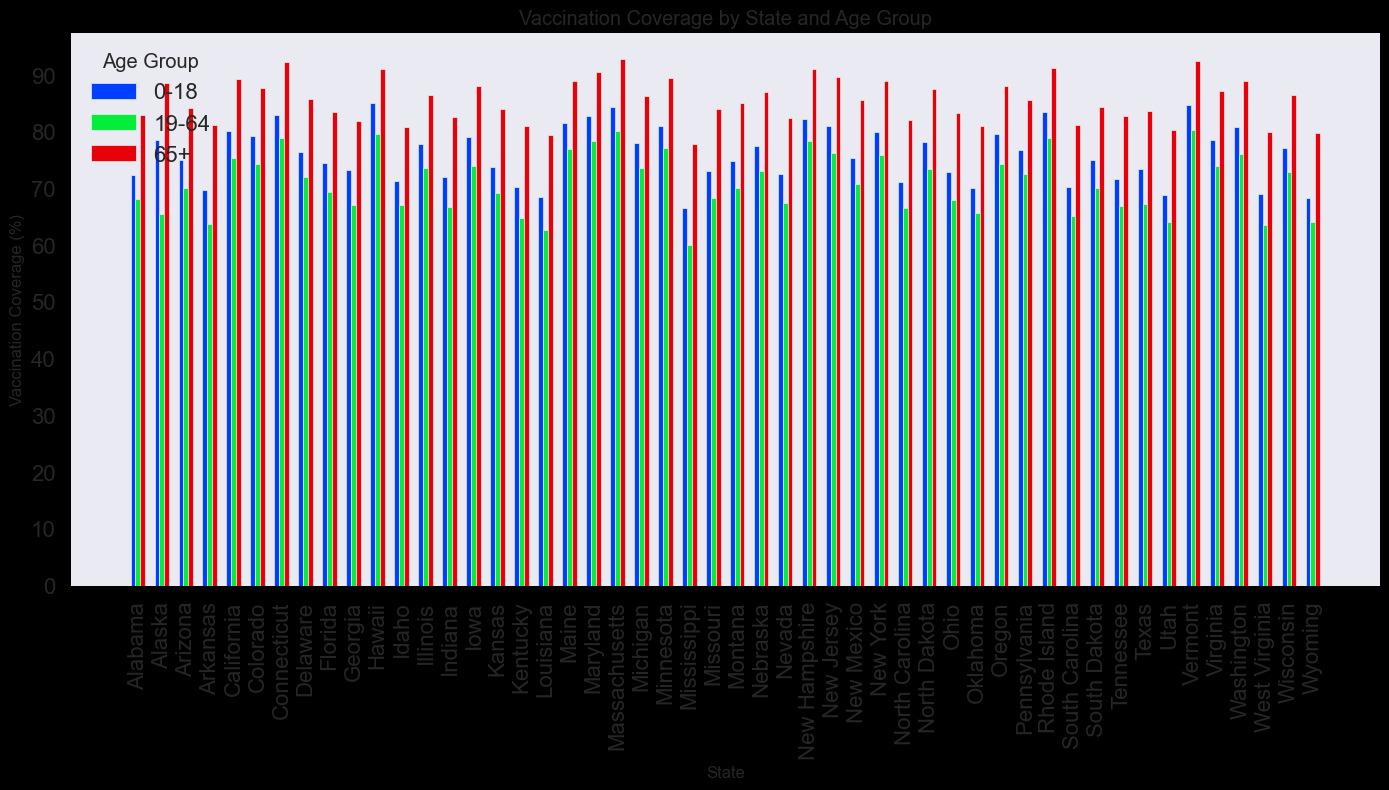Which state has the highest vaccination coverage for the age group 65+? To find the answer, look at the height of the bars representing the 65+ age group for all states. Identify the state with the tallest bar.
Answer: Massachusetts Which age group has the lowest vaccination coverage in Mississippi? Compare the height of the bars for the different age groups in Mississippi. The shortest bar represents the lowest coverage.
Answer: 19-64 Is the vaccination coverage for the 0-18 age group higher in California or Florida? Compare the heights of the bars representing the 0-18 age group for California and Florida. The taller bar indicates higher coverage.
Answer: California What is the average vaccination coverage for the 19-64 age group in Alabama, Alaska, and Arizona? Find the bars for the 19-64 group in these states and sum their percentages, then divide by 3. Calculation: (68.2 + 65.4 + 70.1) / 3 = 67.9
Answer: 67.9 How much higher is the 65+ vaccination coverage in Vermont compared to Alabama? Identify the bars representing the 65+ group in Vermont and Alabama, subtract Alabama's percentage from Vermont's. Calculation: 92.5 - 82.9 = 9.6
Answer: 9.6 Which state has the lowest overall vaccination coverage for the 0-18 age group? Scan the height of the bars representing the 0-18 age group for all states. Identify the shortest bar.
Answer: Mississippi Does New York or New Jersey have higher vaccination coverage for the 19-64 age group? Compare the bars for the 19-64 group in New York and New Jersey. The taller bar indicates higher coverage.
Answer: New York What is the range of vaccination coverage for the 65+ age group across all states? Identify the highest and lowest percentages for the 65+ group, then subtract the lowest from the highest. Highest: 92.8 (Massachusetts), Lowest: 77.8 (Mississippi). Calculation: 92.8 - 77.8 = 15
Answer: 15 Which age group shows the most variability in vaccination coverage across all states? Assess the range of heights of the bars for each age group across all states. The age group with the largest range shows the most variability. Compare by looking at the range of visual height differences consistently.
Answer: 65+ What's the median vaccination coverage for the 0-18 age group? List the vaccination coverage values for 0-18 for all states, sort them, and determine the middle value. If even number, average the two middle numbers. Sorted values: 66.5, 68.3, 68.5, 68.9, 69.0, 69.7, 70.1, 70.2, 70.3, 71.2, 71.3, 72.0, 72.4, 72.6, 72.8, 73.0, 73.2, 73.4, 73.8, 74.5, 74.8, 75.0, 75.0, 75.4, 76.4, 76.8, 77.1, 77.5, 77.8, 78.0, 78.1, 78.5, 78.5, 79.0, 79.2, 79.6, 80.0, 80.1, 80.8, 81.0, 81.0, 81.5, 82.3, 82.7, 83.0, 83.5, 84.3, 84.7, 85.0. Middle values: 73.4, 73.8. Median Calculation: (73.4 + 73.8) / 2 = 73.6
Answer: 73.6 